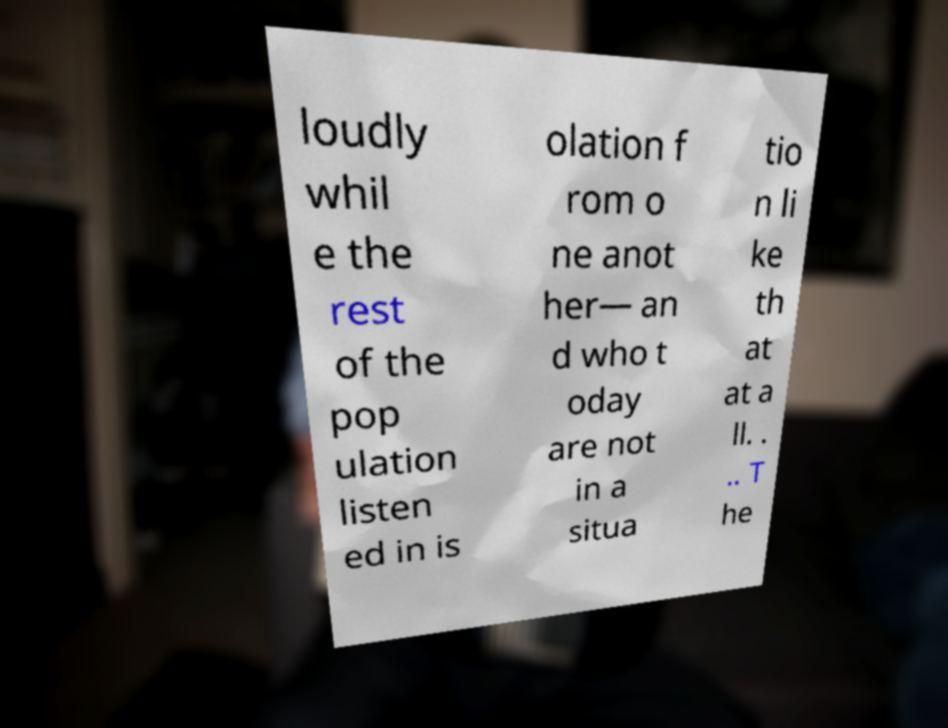Can you accurately transcribe the text from the provided image for me? loudly whil e the rest of the pop ulation listen ed in is olation f rom o ne anot her— an d who t oday are not in a situa tio n li ke th at at a ll. . .. T he 